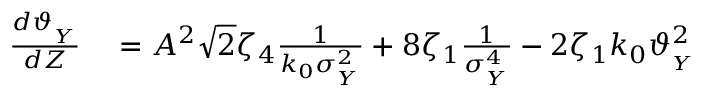<formula> <loc_0><loc_0><loc_500><loc_500>\begin{array} { r l } { \frac { d \vartheta _ { _ { Y } } } { d Z } } & = A ^ { 2 } \sqrt { 2 } \zeta _ { 4 } \frac { 1 } { k _ { 0 } \sigma _ { _ { Y } } ^ { 2 } } + 8 \zeta _ { 1 } \frac { 1 } { \sigma _ { _ { Y } } ^ { 4 } } - 2 \zeta _ { 1 } k _ { 0 } \vartheta _ { _ { Y } } ^ { 2 } } \end{array}</formula> 